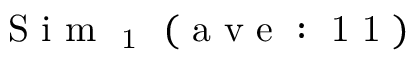Convert formula to latex. <formula><loc_0><loc_0><loc_500><loc_500>S i m _ { 1 } ( a v e \colon 1 1 )</formula> 